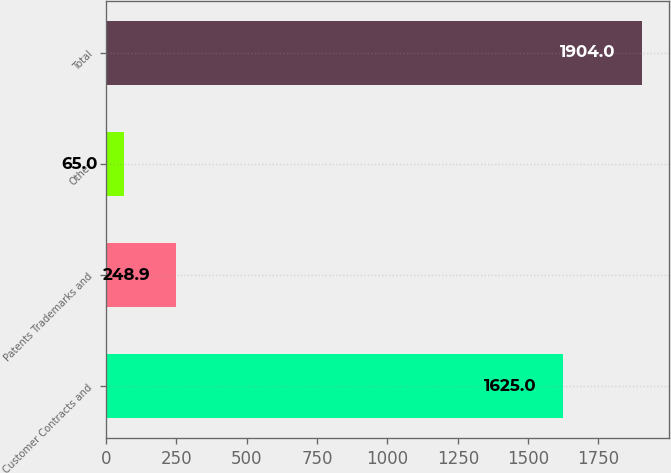Convert chart. <chart><loc_0><loc_0><loc_500><loc_500><bar_chart><fcel>Customer Contracts and<fcel>Patents Trademarks and<fcel>Other<fcel>Total<nl><fcel>1625<fcel>248.9<fcel>65<fcel>1904<nl></chart> 